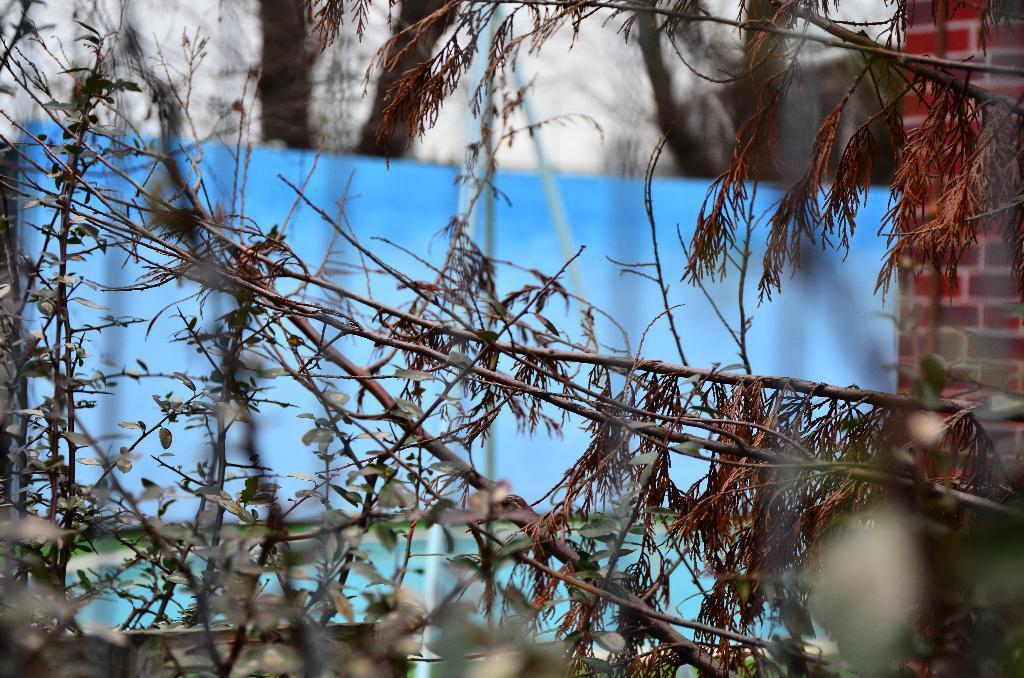Could you give a brief overview of what you see in this image? In this picture I can see plants and trees. On the right I can see the brick wall. In the back I can see the blue color cloth. At the top background I can see the building. 